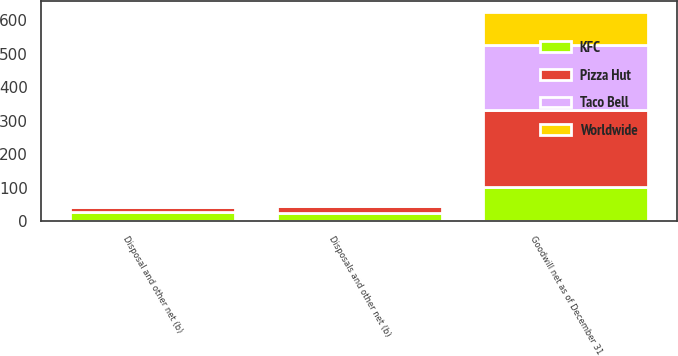Convert chart. <chart><loc_0><loc_0><loc_500><loc_500><stacked_bar_chart><ecel><fcel>Goodwill net as of December 31<fcel>Disposals and other net (b)<fcel>Disposal and other net (b)<nl><fcel>Pizza Hut<fcel>230<fcel>21<fcel>17<nl><fcel>Taco Bell<fcel>196<fcel>5<fcel>5<nl><fcel>Worldwide<fcel>99<fcel>8<fcel>4<nl><fcel>KFC<fcel>101<fcel>24<fcel>26<nl></chart> 